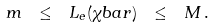<formula> <loc_0><loc_0><loc_500><loc_500>m \ \leq \ L _ { e } ( \chi b a r ) \ \leq \ M \, .</formula> 